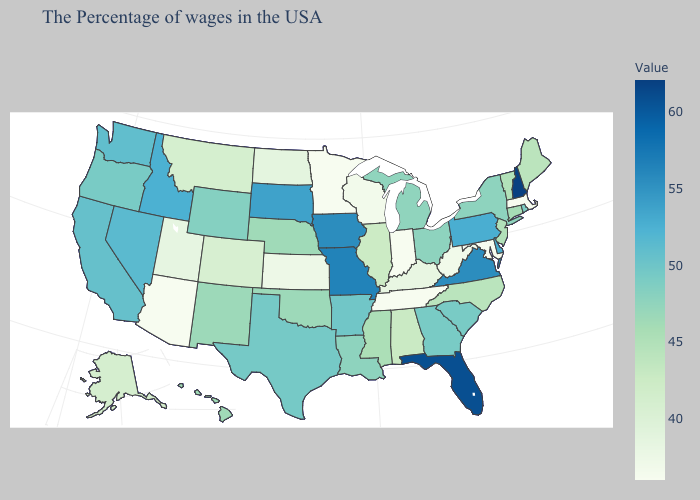Among the states that border California , which have the highest value?
Concise answer only. Nevada. Among the states that border New Jersey , does New York have the lowest value?
Short answer required. Yes. Does Louisiana have the lowest value in the South?
Keep it brief. No. Does the map have missing data?
Be succinct. No. 